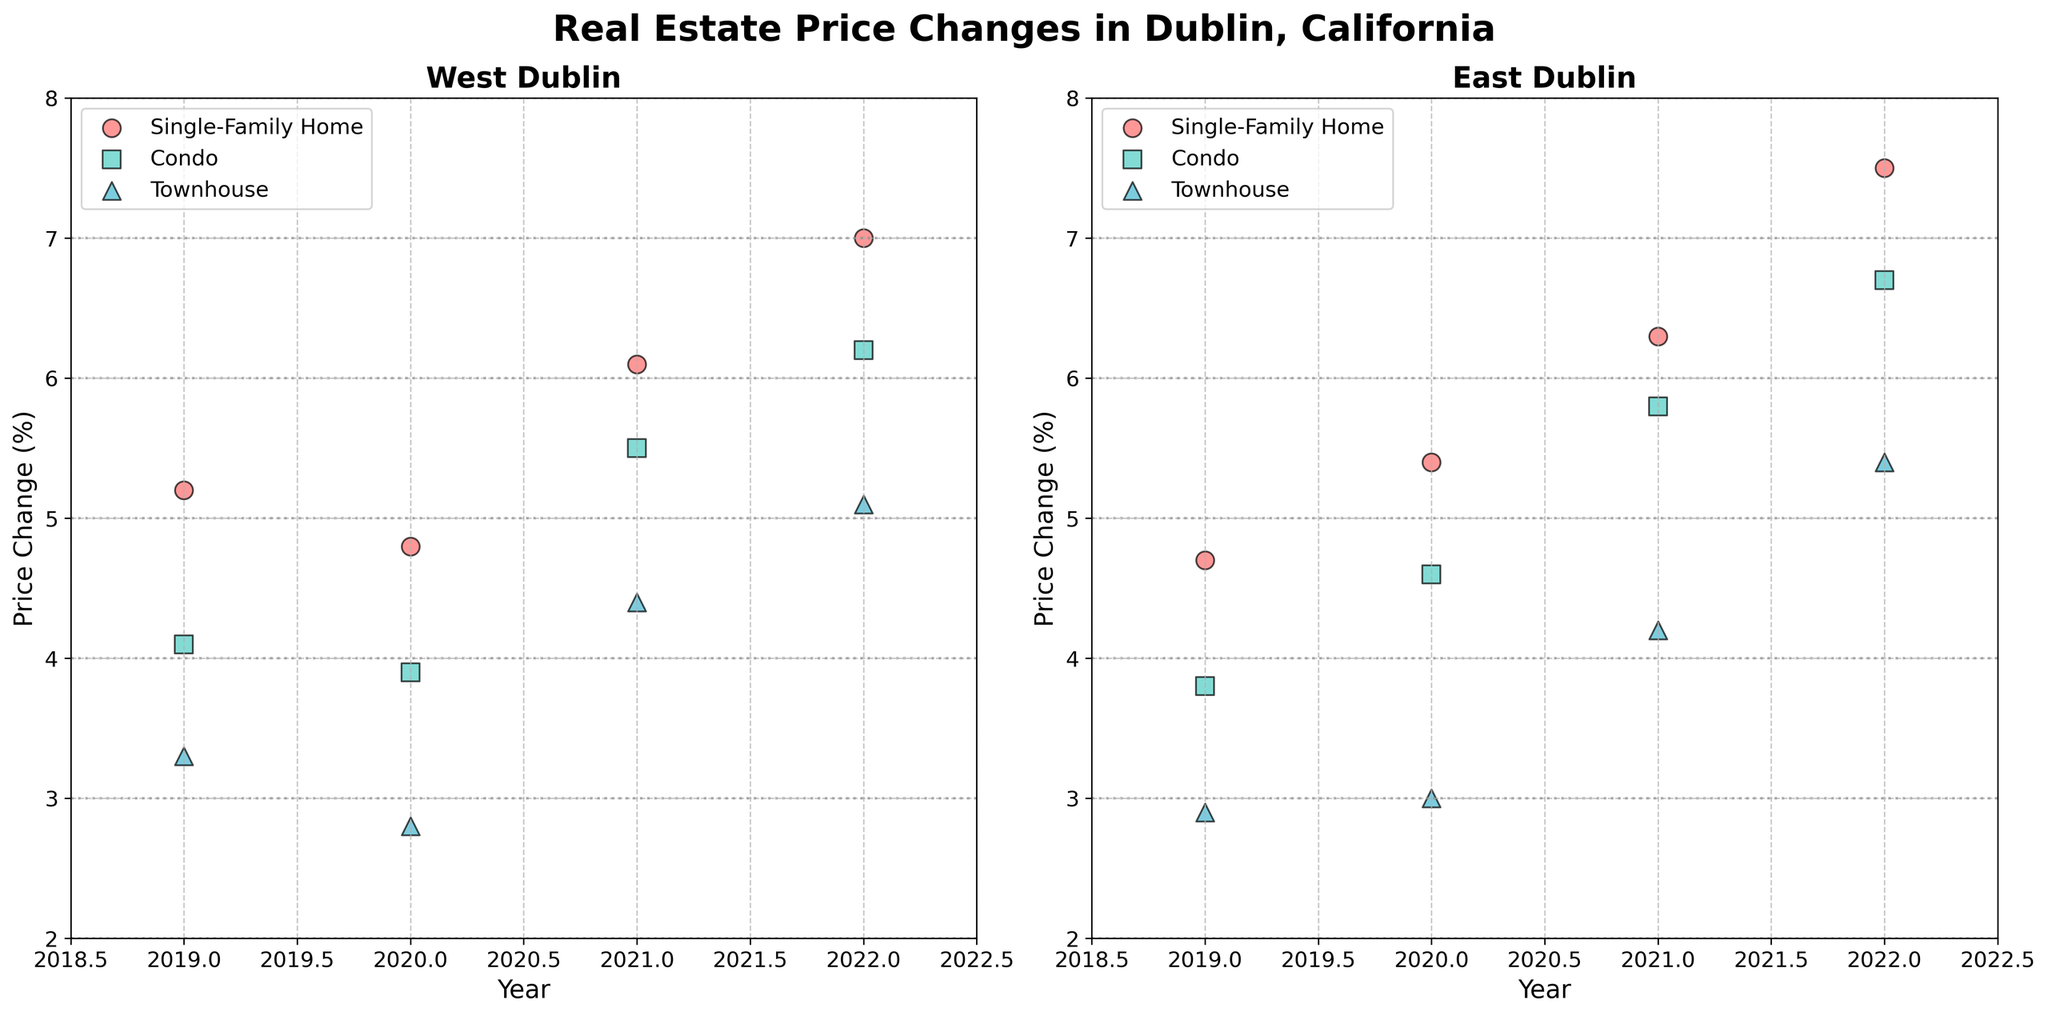what is the title of the figure? The title of the plot is located at the top center, larger and bold than other text elements. It reads: "Real Estate Price Changes in Dublin, California"
Answer: Real Estate Price Changes in Dublin, California which neighborhood had the highest price change for single-family homes in 2022? By observing the scatter plots, the highest price change for single-family homes in 2022 is indicated by the highest point marked in red. In the East Dublin subplot, the value reaches 7.5% which is higher than that in West Dublin
Answer: East Dublin how many property types are there in the plots? By examining the markers and legends, you can see three different types of markers representing three different property types: circles for Single-Family Homes, squares for Condos, and triangles for Townhouses
Answer: 3 which condo showed the least price change overall? Lowest price changes for condos are indicated by green squares closest to the bottom of the y-axis. The lowest occurs in the West Dublin subplot for the year 2020, at 3.9%
Answer: West Dublin in 2020 in which year did West Dublin see the highest price change for townhouses? Observing the points that represent townhouses in the West Dublin subplot (blue triangles), the highest price change is in 2022, reaching around 5.1%
Answer: 2022 compare the price change of single-family homes in both neighborhoods for 2021. which one is higher? In the West Dublin subplot, the red circle in 2021 is positioned at 6.1%. In the East Dublin subplot, the red circle in 2021 is at 6.3%. Thus, East Dublin has a higher price change for this year
Answer: East Dublin what is the general trend in price changes from 2019 to 2022 for condos in both neighborhoods? Observing the green squares for condos from left to right, both subplots show an upward trend from 2019 to 2022, indicating increasing price changes
Answer: Increasing trend which property type had the most stable price change in West Dublin? Stability can be inferred by the consistency of data points along the y-axis. In West Dublin, townhouses (blue triangles) have closer values throughout the years compared to the other property types
Answer: Townhouses which year had the smallest difference in price change between single-family homes and condos in East Dublin? By calculating the differences: 
2019: 4.7 - 3.8 = 0.9
2020: 5.4 - 4.6 = 0.8
2021: 6.3 - 5.8 = 0.5
2022: 7.5 - 6.7 = 0.8 
The smallest difference occurs in 2021 with a difference of 0.5
Answer: 2021 